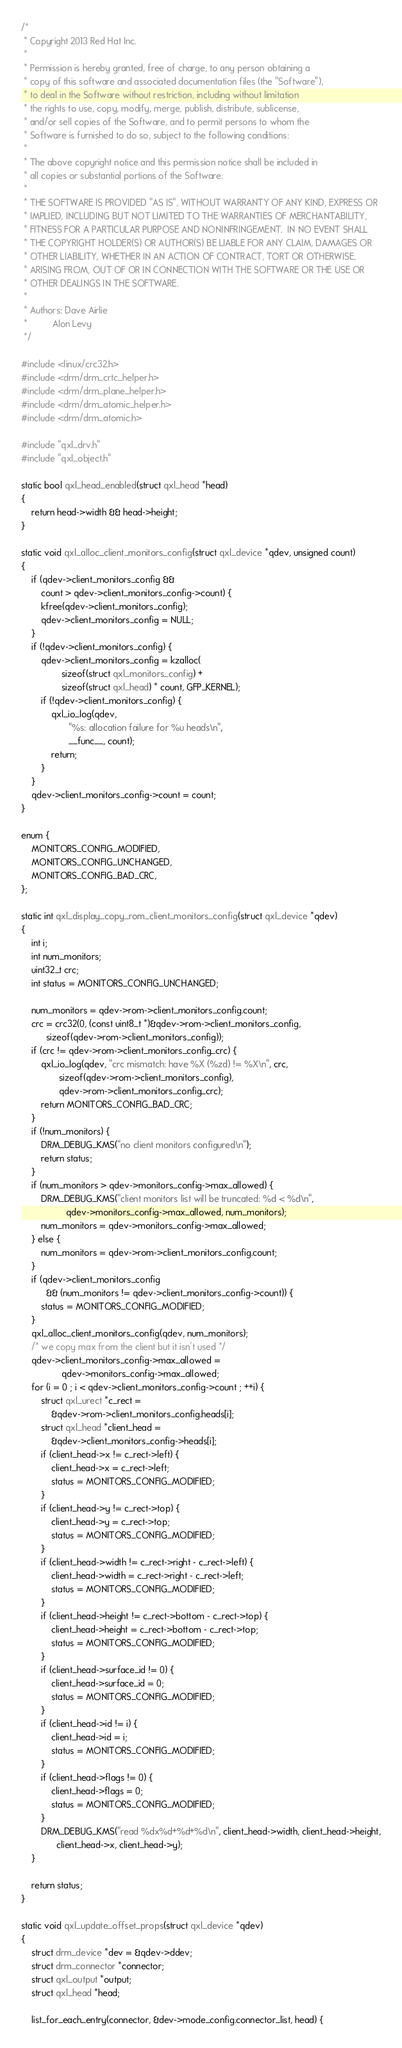Convert code to text. <code><loc_0><loc_0><loc_500><loc_500><_C_>/*
 * Copyright 2013 Red Hat Inc.
 *
 * Permission is hereby granted, free of charge, to any person obtaining a
 * copy of this software and associated documentation files (the "Software"),
 * to deal in the Software without restriction, including without limitation
 * the rights to use, copy, modify, merge, publish, distribute, sublicense,
 * and/or sell copies of the Software, and to permit persons to whom the
 * Software is furnished to do so, subject to the following conditions:
 *
 * The above copyright notice and this permission notice shall be included in
 * all copies or substantial portions of the Software.
 *
 * THE SOFTWARE IS PROVIDED "AS IS", WITHOUT WARRANTY OF ANY KIND, EXPRESS OR
 * IMPLIED, INCLUDING BUT NOT LIMITED TO THE WARRANTIES OF MERCHANTABILITY,
 * FITNESS FOR A PARTICULAR PURPOSE AND NONINFRINGEMENT.  IN NO EVENT SHALL
 * THE COPYRIGHT HOLDER(S) OR AUTHOR(S) BE LIABLE FOR ANY CLAIM, DAMAGES OR
 * OTHER LIABILITY, WHETHER IN AN ACTION OF CONTRACT, TORT OR OTHERWISE,
 * ARISING FROM, OUT OF OR IN CONNECTION WITH THE SOFTWARE OR THE USE OR
 * OTHER DEALINGS IN THE SOFTWARE.
 *
 * Authors: Dave Airlie
 *          Alon Levy
 */

#include <linux/crc32.h>
#include <drm/drm_crtc_helper.h>
#include <drm/drm_plane_helper.h>
#include <drm/drm_atomic_helper.h>
#include <drm/drm_atomic.h>

#include "qxl_drv.h"
#include "qxl_object.h"

static bool qxl_head_enabled(struct qxl_head *head)
{
	return head->width && head->height;
}

static void qxl_alloc_client_monitors_config(struct qxl_device *qdev, unsigned count)
{
	if (qdev->client_monitors_config &&
	    count > qdev->client_monitors_config->count) {
		kfree(qdev->client_monitors_config);
		qdev->client_monitors_config = NULL;
	}
	if (!qdev->client_monitors_config) {
		qdev->client_monitors_config = kzalloc(
				sizeof(struct qxl_monitors_config) +
				sizeof(struct qxl_head) * count, GFP_KERNEL);
		if (!qdev->client_monitors_config) {
			qxl_io_log(qdev,
				   "%s: allocation failure for %u heads\n",
				   __func__, count);
			return;
		}
	}
	qdev->client_monitors_config->count = count;
}

enum {
	MONITORS_CONFIG_MODIFIED,
	MONITORS_CONFIG_UNCHANGED,
	MONITORS_CONFIG_BAD_CRC,
};

static int qxl_display_copy_rom_client_monitors_config(struct qxl_device *qdev)
{
	int i;
	int num_monitors;
	uint32_t crc;
	int status = MONITORS_CONFIG_UNCHANGED;

	num_monitors = qdev->rom->client_monitors_config.count;
	crc = crc32(0, (const uint8_t *)&qdev->rom->client_monitors_config,
		  sizeof(qdev->rom->client_monitors_config));
	if (crc != qdev->rom->client_monitors_config_crc) {
		qxl_io_log(qdev, "crc mismatch: have %X (%zd) != %X\n", crc,
			   sizeof(qdev->rom->client_monitors_config),
			   qdev->rom->client_monitors_config_crc);
		return MONITORS_CONFIG_BAD_CRC;
	}
	if (!num_monitors) {
		DRM_DEBUG_KMS("no client monitors configured\n");
		return status;
	}
	if (num_monitors > qdev->monitors_config->max_allowed) {
		DRM_DEBUG_KMS("client monitors list will be truncated: %d < %d\n",
			      qdev->monitors_config->max_allowed, num_monitors);
		num_monitors = qdev->monitors_config->max_allowed;
	} else {
		num_monitors = qdev->rom->client_monitors_config.count;
	}
	if (qdev->client_monitors_config
	      && (num_monitors != qdev->client_monitors_config->count)) {
		status = MONITORS_CONFIG_MODIFIED;
	}
	qxl_alloc_client_monitors_config(qdev, num_monitors);
	/* we copy max from the client but it isn't used */
	qdev->client_monitors_config->max_allowed =
				qdev->monitors_config->max_allowed;
	for (i = 0 ; i < qdev->client_monitors_config->count ; ++i) {
		struct qxl_urect *c_rect =
			&qdev->rom->client_monitors_config.heads[i];
		struct qxl_head *client_head =
			&qdev->client_monitors_config->heads[i];
		if (client_head->x != c_rect->left) {
			client_head->x = c_rect->left;
			status = MONITORS_CONFIG_MODIFIED;
		}
		if (client_head->y != c_rect->top) {
			client_head->y = c_rect->top;
			status = MONITORS_CONFIG_MODIFIED;
		}
		if (client_head->width != c_rect->right - c_rect->left) {
			client_head->width = c_rect->right - c_rect->left;
			status = MONITORS_CONFIG_MODIFIED;
		}
		if (client_head->height != c_rect->bottom - c_rect->top) {
			client_head->height = c_rect->bottom - c_rect->top;
			status = MONITORS_CONFIG_MODIFIED;
		}
		if (client_head->surface_id != 0) {
			client_head->surface_id = 0;
			status = MONITORS_CONFIG_MODIFIED;
		}
		if (client_head->id != i) {
			client_head->id = i;
			status = MONITORS_CONFIG_MODIFIED;
		}
		if (client_head->flags != 0) {
			client_head->flags = 0;
			status = MONITORS_CONFIG_MODIFIED;
		}
		DRM_DEBUG_KMS("read %dx%d+%d+%d\n", client_head->width, client_head->height,
			  client_head->x, client_head->y);
	}

	return status;
}

static void qxl_update_offset_props(struct qxl_device *qdev)
{
	struct drm_device *dev = &qdev->ddev;
	struct drm_connector *connector;
	struct qxl_output *output;
	struct qxl_head *head;

	list_for_each_entry(connector, &dev->mode_config.connector_list, head) {</code> 